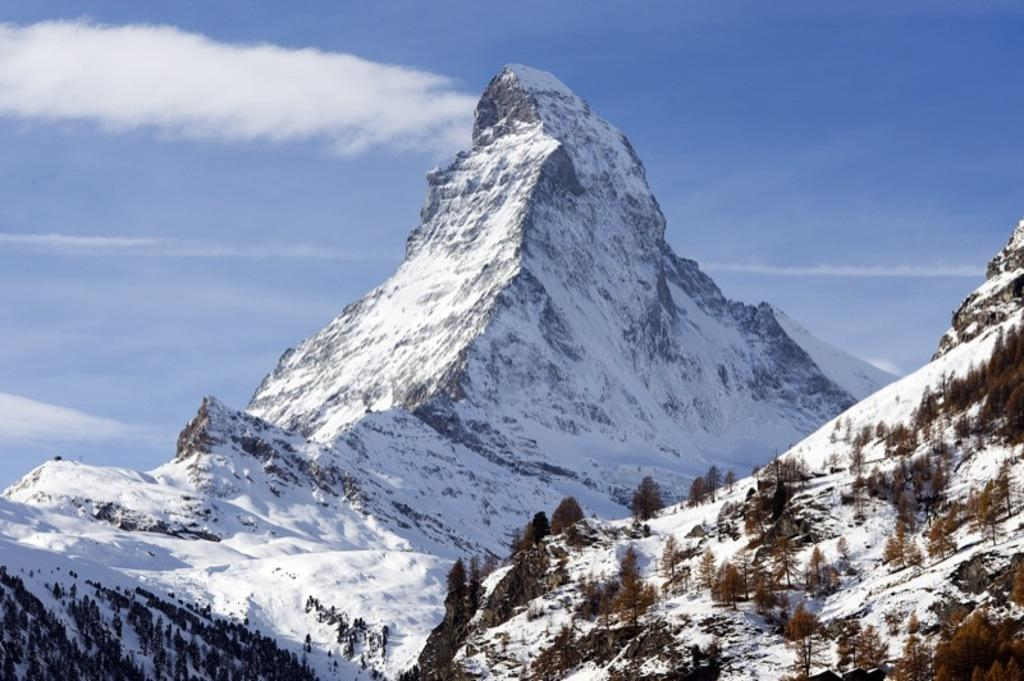How many mountains can be seen in the image? There are two mountains in the image. What type of vegetation is present in the image? There are many trees in the image. How would you describe the sky in the image? The sky is blue and slightly cloudy in the image. What type of dog can be seen playing in the image? There is no dog present in the image; it features two mountains, many trees, and a blue, slightly cloudy sky. 